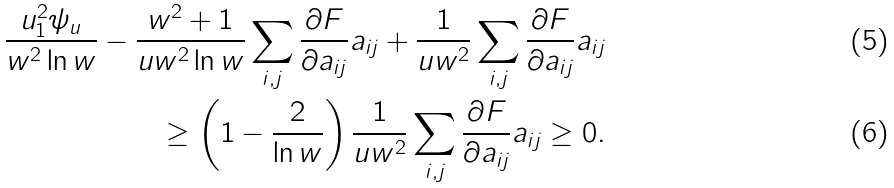<formula> <loc_0><loc_0><loc_500><loc_500>\frac { u ^ { 2 } _ { 1 } \psi _ { u } } { w ^ { 2 } \ln w } - \frac { w ^ { 2 } + 1 } { u w ^ { 2 } \ln w } \sum _ { i , j } \frac { \partial F } { \partial a _ { i j } } a _ { i j } + \frac { 1 } { u w ^ { 2 } } \sum _ { i , j } \frac { \partial F } { \partial a _ { i j } } a _ { i j } \\ \geq \left ( 1 - \frac { 2 } { \ln w } \right ) \frac { 1 } { u w ^ { 2 } } \sum _ { i , j } \frac { \partial F } { \partial a _ { i j } } a _ { i j } \geq 0 .</formula> 